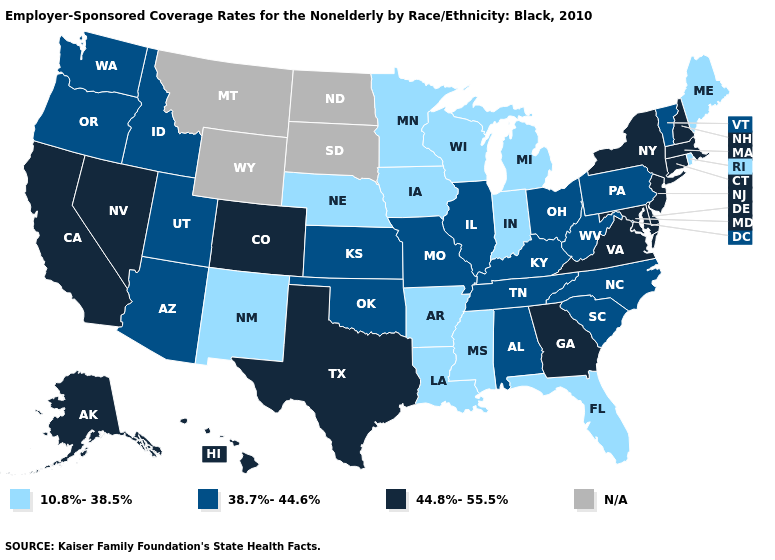What is the value of South Carolina?
Keep it brief. 38.7%-44.6%. Does Nebraska have the lowest value in the MidWest?
Short answer required. Yes. Does the map have missing data?
Answer briefly. Yes. Name the states that have a value in the range N/A?
Give a very brief answer. Montana, North Dakota, South Dakota, Wyoming. Does Florida have the lowest value in the South?
Concise answer only. Yes. Which states have the lowest value in the MidWest?
Answer briefly. Indiana, Iowa, Michigan, Minnesota, Nebraska, Wisconsin. Name the states that have a value in the range 10.8%-38.5%?
Give a very brief answer. Arkansas, Florida, Indiana, Iowa, Louisiana, Maine, Michigan, Minnesota, Mississippi, Nebraska, New Mexico, Rhode Island, Wisconsin. What is the highest value in states that border North Dakota?
Short answer required. 10.8%-38.5%. Name the states that have a value in the range 38.7%-44.6%?
Be succinct. Alabama, Arizona, Idaho, Illinois, Kansas, Kentucky, Missouri, North Carolina, Ohio, Oklahoma, Oregon, Pennsylvania, South Carolina, Tennessee, Utah, Vermont, Washington, West Virginia. What is the value of Arizona?
Be succinct. 38.7%-44.6%. Name the states that have a value in the range 44.8%-55.5%?
Concise answer only. Alaska, California, Colorado, Connecticut, Delaware, Georgia, Hawaii, Maryland, Massachusetts, Nevada, New Hampshire, New Jersey, New York, Texas, Virginia. Does Louisiana have the highest value in the South?
Keep it brief. No. Among the states that border Idaho , which have the highest value?
Quick response, please. Nevada. What is the value of Vermont?
Write a very short answer. 38.7%-44.6%. 